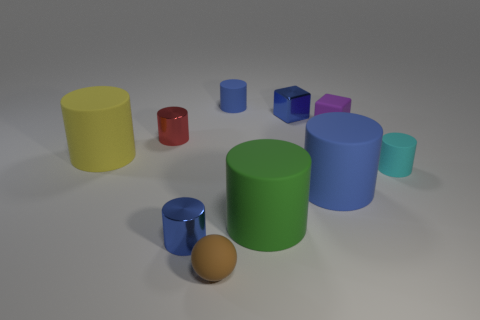How many blue cylinders must be subtracted to get 1 blue cylinders? 2 Subtract all cyan cubes. How many blue cylinders are left? 3 Subtract 1 cylinders. How many cylinders are left? 6 Subtract all red cylinders. How many cylinders are left? 6 Subtract all tiny blue metallic cylinders. How many cylinders are left? 6 Subtract all red cylinders. Subtract all brown cubes. How many cylinders are left? 6 Subtract all cylinders. How many objects are left? 3 Subtract all red rubber blocks. Subtract all blue cubes. How many objects are left? 9 Add 6 small blue metal cylinders. How many small blue metal cylinders are left? 7 Add 5 matte cubes. How many matte cubes exist? 6 